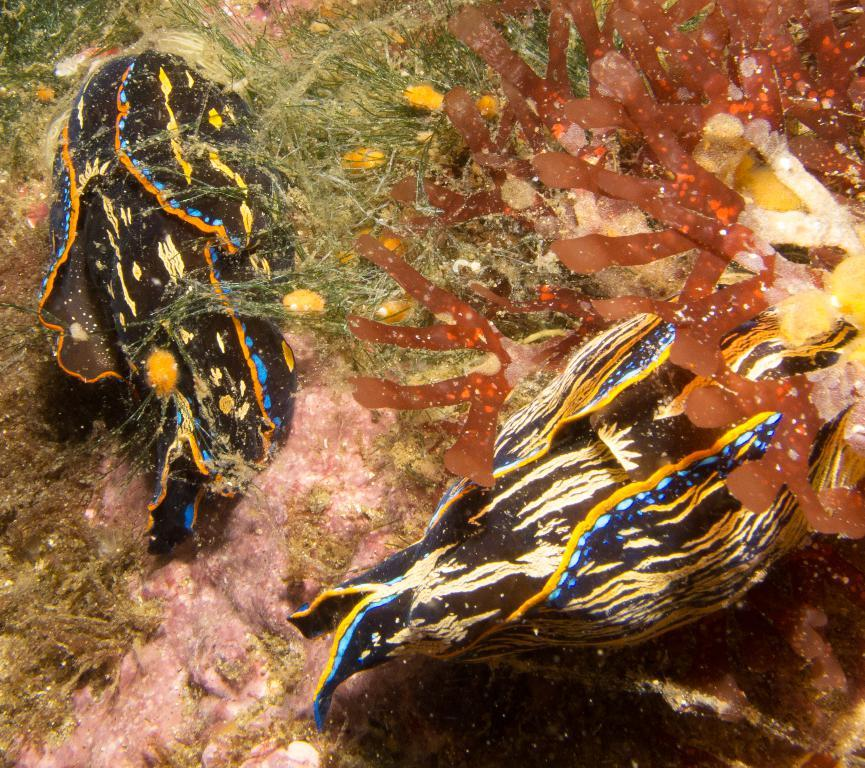What type of animals can be seen in the image? There are fishes in the image. What type of plant life is present in the image? There is algae in the image. Where are the fishes and algae located? The fishes and algae are in the water. How many bikes are visible in the image? There are no bikes present in the image. What type of selection process is used to determine the fishes' colors in the image? There is no indication of a selection process for the fishes' colors in the image; they are naturally occurring. 